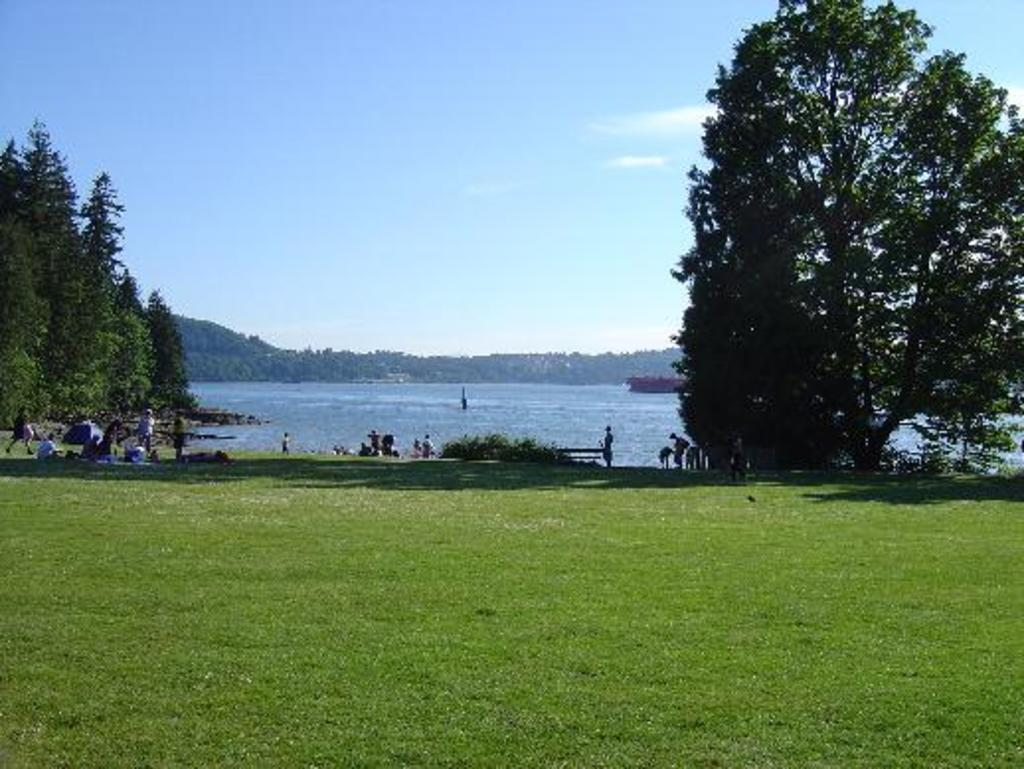Who or what can be seen in the image? There are people in the image. What type of natural environment is depicted in the image? There are trees in the image, and the ground is covered with grass. What is visible at the bottom of the image? There is water visible at the bottom of the image. What part of the natural environment is visible at the top of the image? The sky is visible at the top of the image. What type of pies are being baked by the writer in the image? There is no writer or pies present in the image. 